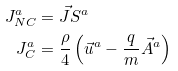Convert formula to latex. <formula><loc_0><loc_0><loc_500><loc_500>J _ { N C } ^ { a } & = \vec { J } S ^ { a } \\ J _ { C } ^ { a } & = \frac { \rho } { 4 } \left ( \vec { u } ^ { a } - \frac { q } { m } \vec { A } ^ { a } \right )</formula> 